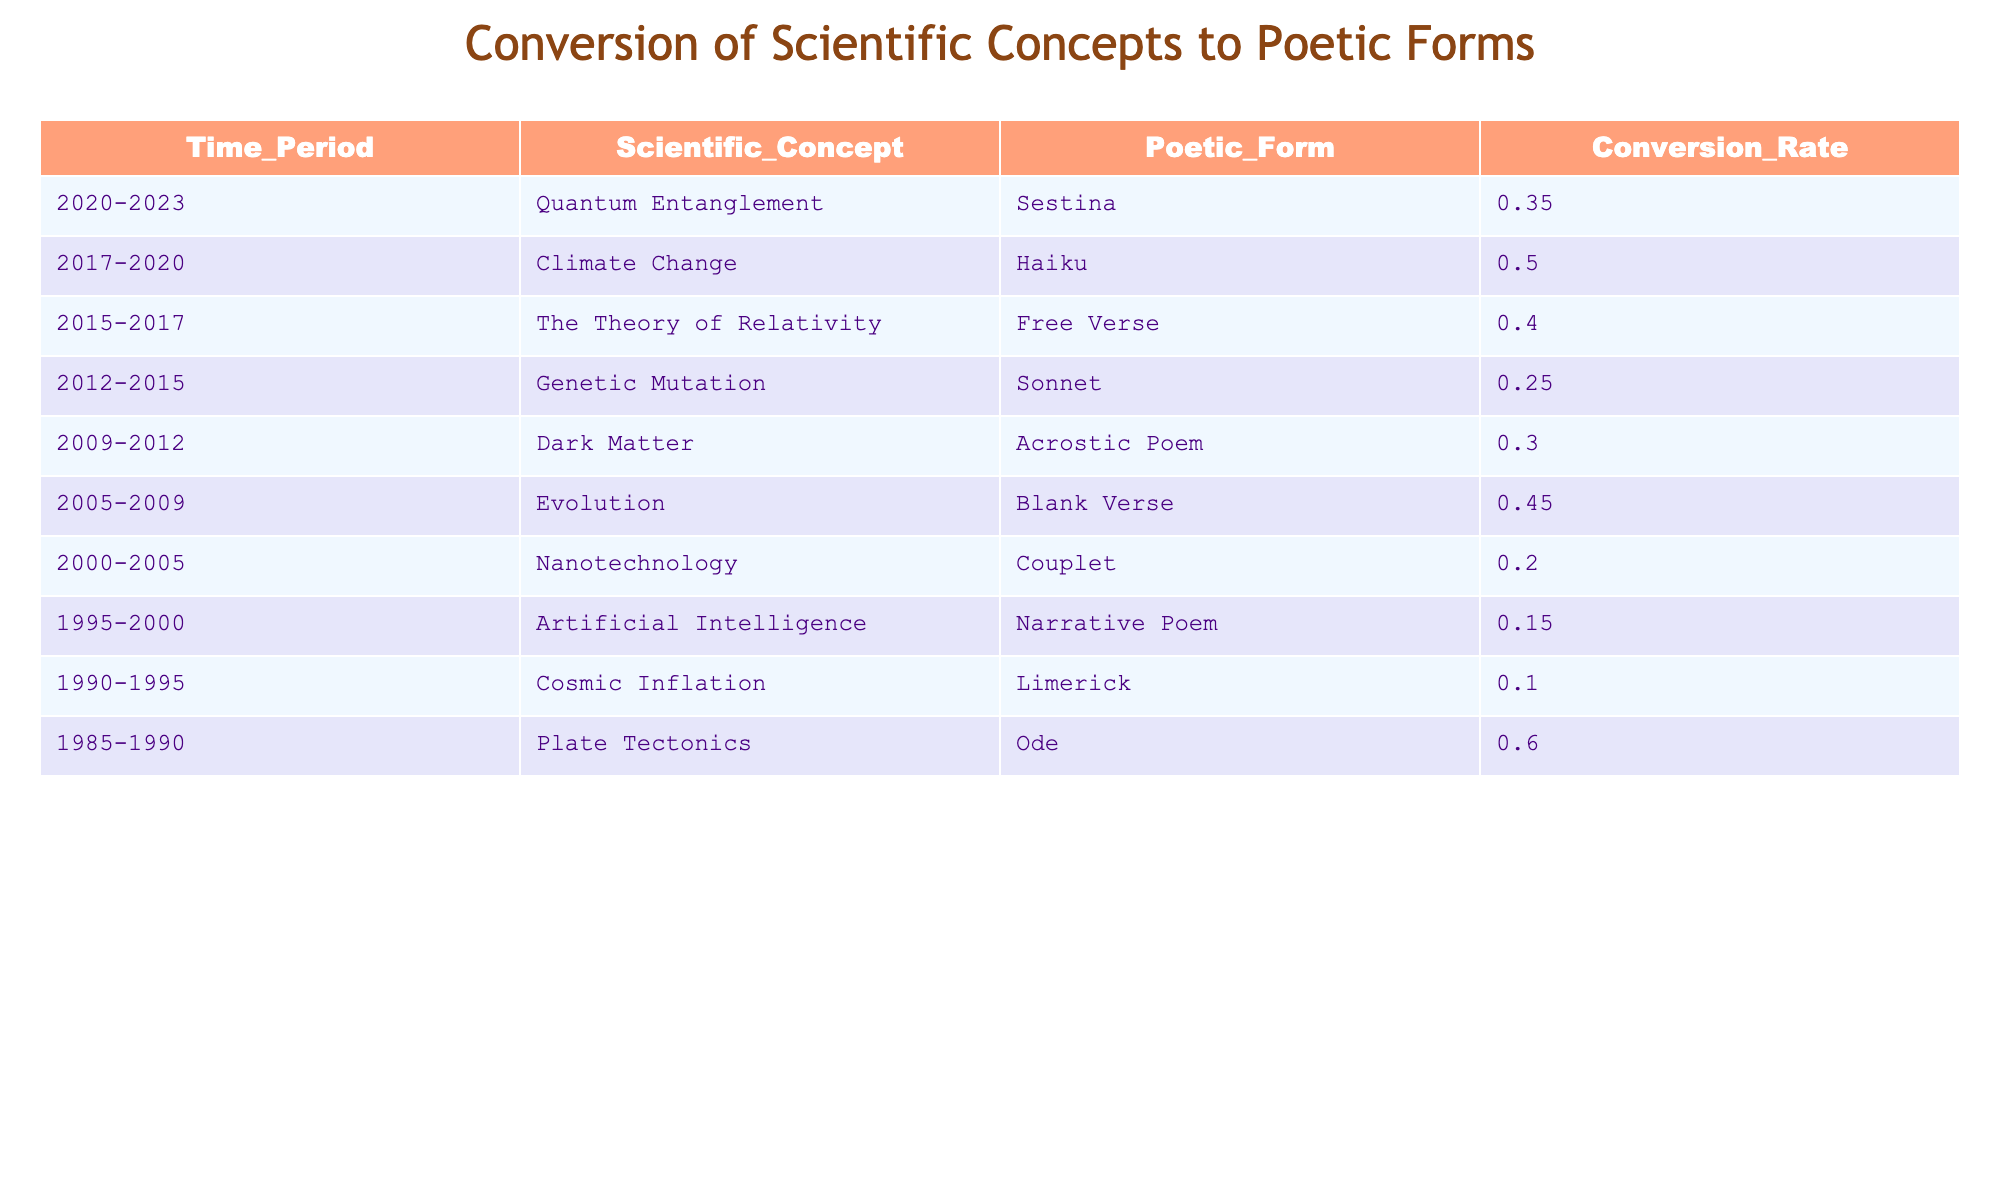What is the conversion rate for Quantum Entanglement? The table shows that the conversion rate for Quantum Entanglement is 0.35. This is directly retrieved from the row corresponding to the years 2020-2023.
Answer: 0.35 Which poetic form has the highest conversion rate? Looking into the table, the poetic form with the highest conversion rate is Ode, with a conversion rate of 0.60 from the time period 1985-1990.
Answer: Ode What is the average conversion rate for all scientific concepts from 2000 to 2023? To find the average, I will sum the conversion rates for the periods 2000-2023: (0.20 + 0.15 + 0.10 + 0.60 + 0.45 + 0.40 + 0.50 + 0.35) = 2.25. There are 8 data points, so the average conversion rate is 2.25 / 8 = 0.28125, which can be rounded to 0.28.
Answer: 0.28 Did the conversion rate for Plate Tectonics exceed 0.50? The conversion rate for Plate Tectonics is 0.60 according to the table. Therefore, the statement is true, as it is greater than 0.50.
Answer: Yes How many scientific concepts have a conversion rate lower than 0.30? By examining the table, the concepts with a conversion rate lower than 0.30 are Genetic Mutation (0.25), Nanotechnology (0.20), and Artificial Intelligence (0.15). This totals three scientific concepts that fall into this category.
Answer: 3 What is the conversion rate difference between Climate Change and The Theory of Relativity? The conversion rate for Climate Change is 0.50 and for The Theory of Relativity is 0.40. The difference can be calculated as 0.50 - 0.40 = 0.10.
Answer: 0.10 Was the poetic form for Genetic Mutation more or less frequently converted compared to the poetic form for Evolution? The conversion rate for Genetic Mutation is 0.25 and for Evolution it is 0.45. Since 0.25 is less than 0.45, it means Genetic Mutation was less frequently converted.
Answer: Less What proportion of the poetic forms listed had a conversion rate of 0.40 or higher? The conversion rates of 0.40 or higher are: Quantum Entanglement (0.35), Climate Change (0.50), The Theory of Relativity (0.40), Evolution (0.45), and Plate Tectonics (0.60). There are 5 of these compared to a total of 10 forms, making the proportion 5/10 = 0.50.
Answer: 0.50 Which scientific concept from the period 2005-2009 had the highest conversion rate? In the period 2005-2009, Evolution has the highest conversion rate of 0.45 in the table. It is identified by specifically looking at the corresponding row.
Answer: Evolution 